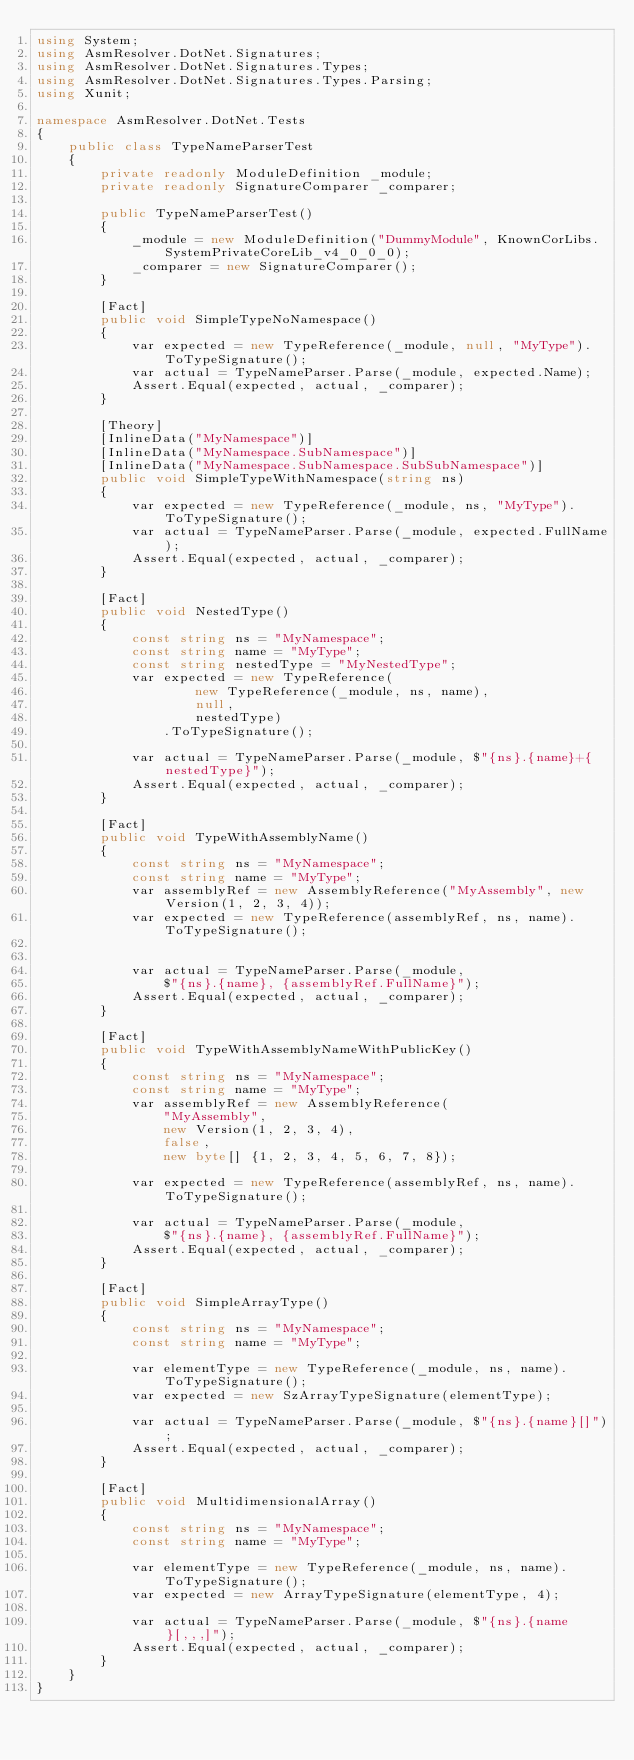Convert code to text. <code><loc_0><loc_0><loc_500><loc_500><_C#_>using System;
using AsmResolver.DotNet.Signatures;
using AsmResolver.DotNet.Signatures.Types;
using AsmResolver.DotNet.Signatures.Types.Parsing;
using Xunit;

namespace AsmResolver.DotNet.Tests
{
    public class TypeNameParserTest
    {
        private readonly ModuleDefinition _module;
        private readonly SignatureComparer _comparer;

        public TypeNameParserTest()
        {
            _module = new ModuleDefinition("DummyModule", KnownCorLibs.SystemPrivateCoreLib_v4_0_0_0);
            _comparer = new SignatureComparer();
        }
        
        [Fact]
        public void SimpleTypeNoNamespace()
        {
            var expected = new TypeReference(_module, null, "MyType").ToTypeSignature();
            var actual = TypeNameParser.Parse(_module, expected.Name);
            Assert.Equal(expected, actual, _comparer);
        }
        
        [Theory]
        [InlineData("MyNamespace")]
        [InlineData("MyNamespace.SubNamespace")]
        [InlineData("MyNamespace.SubNamespace.SubSubNamespace")]
        public void SimpleTypeWithNamespace(string ns)
        {
            var expected = new TypeReference(_module, ns, "MyType").ToTypeSignature();
            var actual = TypeNameParser.Parse(_module, expected.FullName);
            Assert.Equal(expected, actual, _comparer);
        }
        
        [Fact]
        public void NestedType()
        {
            const string ns = "MyNamespace";
            const string name = "MyType";
            const string nestedType = "MyNestedType";
            var expected = new TypeReference(
                    new TypeReference(_module, ns, name),
                    null,
                    nestedType)
                .ToTypeSignature();
            
            var actual = TypeNameParser.Parse(_module, $"{ns}.{name}+{nestedType}");
            Assert.Equal(expected, actual, _comparer);
        }

        [Fact]
        public void TypeWithAssemblyName()
        {
            const string ns = "MyNamespace";
            const string name = "MyType";
            var assemblyRef = new AssemblyReference("MyAssembly", new Version(1, 2, 3, 4));
            var expected = new TypeReference(assemblyRef, ns, name).ToTypeSignature();
            
            
            var actual = TypeNameParser.Parse(_module, 
                $"{ns}.{name}, {assemblyRef.FullName}");
            Assert.Equal(expected, actual, _comparer);
        }

        [Fact]
        public void TypeWithAssemblyNameWithPublicKey()
        {
            const string ns = "MyNamespace";
            const string name = "MyType";
            var assemblyRef = new AssemblyReference(
                "MyAssembly",
                new Version(1, 2, 3, 4),
                false,
                new byte[] {1, 2, 3, 4, 5, 6, 7, 8});
            
            var expected = new TypeReference(assemblyRef, ns, name).ToTypeSignature();

            var actual = TypeNameParser.Parse(_module, 
                $"{ns}.{name}, {assemblyRef.FullName}");
            Assert.Equal(expected, actual, _comparer);
        }

        [Fact]
        public void SimpleArrayType()
        {
            const string ns = "MyNamespace";
            const string name = "MyType";
            
            var elementType = new TypeReference(_module, ns, name).ToTypeSignature();
            var expected = new SzArrayTypeSignature(elementType);

            var actual = TypeNameParser.Parse(_module, $"{ns}.{name}[]");
            Assert.Equal(expected, actual, _comparer);
        }

        [Fact]
        public void MultidimensionalArray()
        {
            const string ns = "MyNamespace";
            const string name = "MyType";
            
            var elementType = new TypeReference(_module, ns, name).ToTypeSignature();
            var expected = new ArrayTypeSignature(elementType, 4);

            var actual = TypeNameParser.Parse(_module, $"{ns}.{name}[,,,]");
            Assert.Equal(expected, actual, _comparer);
        }
    }
}</code> 